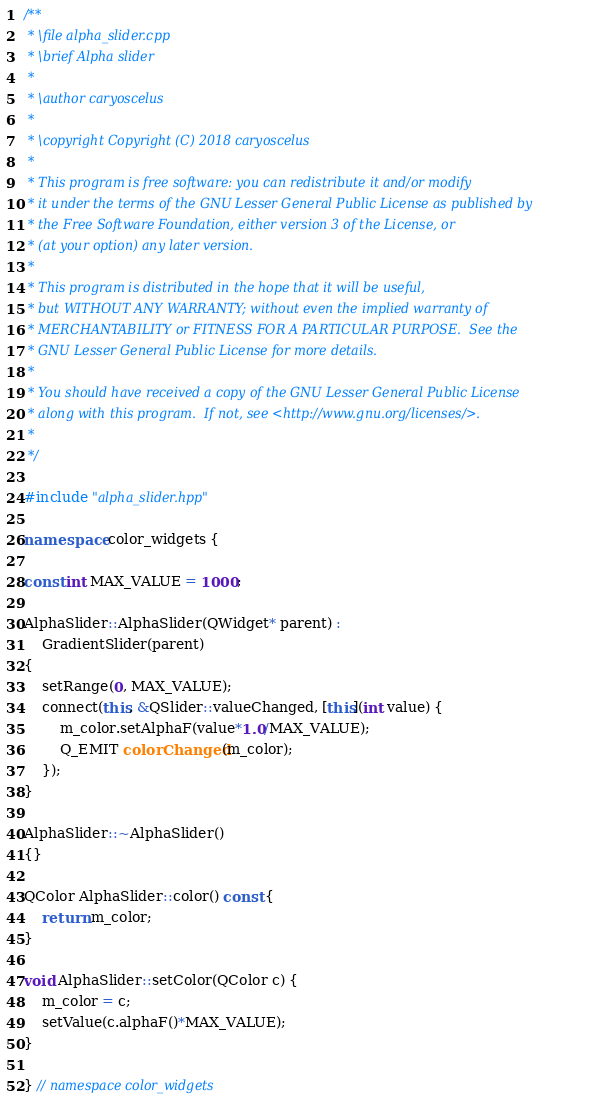<code> <loc_0><loc_0><loc_500><loc_500><_C++_>/**
 * \file alpha_slider.cpp
 * \brief Alpha slider
 *
 * \author caryoscelus
 *
 * \copyright Copyright (C) 2018 caryoscelus
 *
 * This program is free software: you can redistribute it and/or modify
 * it under the terms of the GNU Lesser General Public License as published by
 * the Free Software Foundation, either version 3 of the License, or
 * (at your option) any later version.
 *
 * This program is distributed in the hope that it will be useful,
 * but WITHOUT ANY WARRANTY; without even the implied warranty of
 * MERCHANTABILITY or FITNESS FOR A PARTICULAR PURPOSE.  See the
 * GNU Lesser General Public License for more details.
 *
 * You should have received a copy of the GNU Lesser General Public License
 * along with this program.  If not, see <http://www.gnu.org/licenses/>.
 *
 */

#include "alpha_slider.hpp"

namespace color_widgets {

const int MAX_VALUE = 1000;

AlphaSlider::AlphaSlider(QWidget* parent) :
    GradientSlider(parent)
{
    setRange(0, MAX_VALUE);
    connect(this, &QSlider::valueChanged, [this](int value) {
        m_color.setAlphaF(value*1.0/MAX_VALUE);
        Q_EMIT colorChanged(m_color);
    });
}

AlphaSlider::~AlphaSlider()
{}

QColor AlphaSlider::color() const {
    return m_color;
}

void AlphaSlider::setColor(QColor c) {
    m_color = c;
    setValue(c.alphaF()*MAX_VALUE);
}

} // namespace color_widgets
</code> 